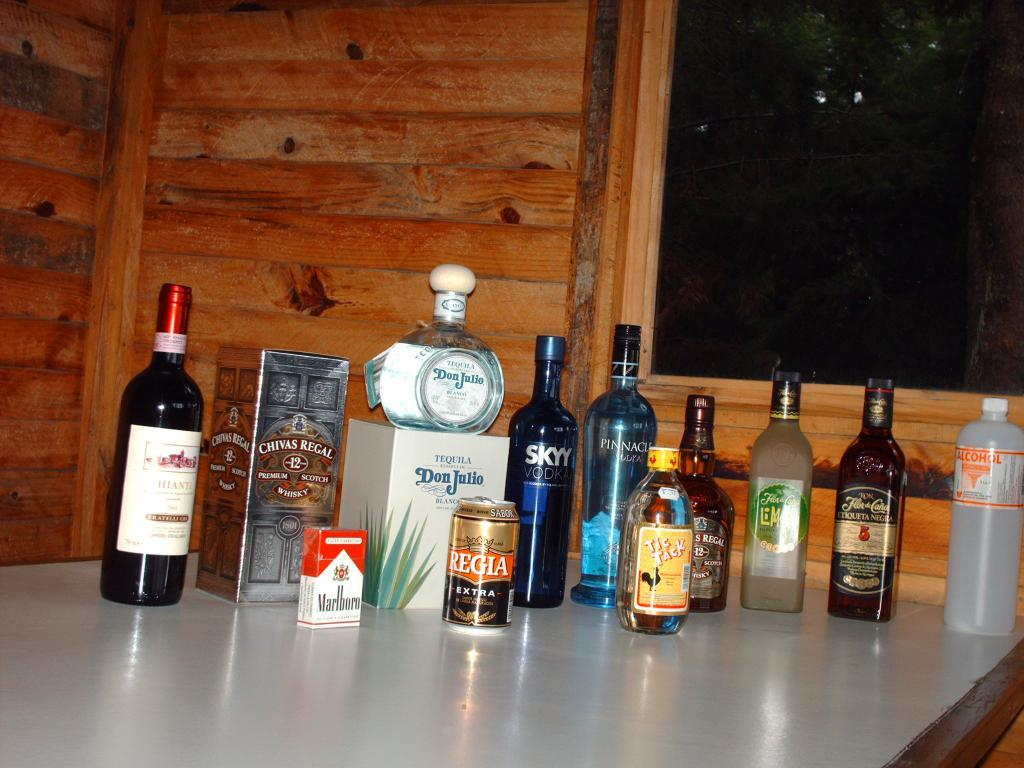<image>
Give a short and clear explanation of the subsequent image. A can of Regia and a bottle of Skyy vodka sit with other drinks on a table. 